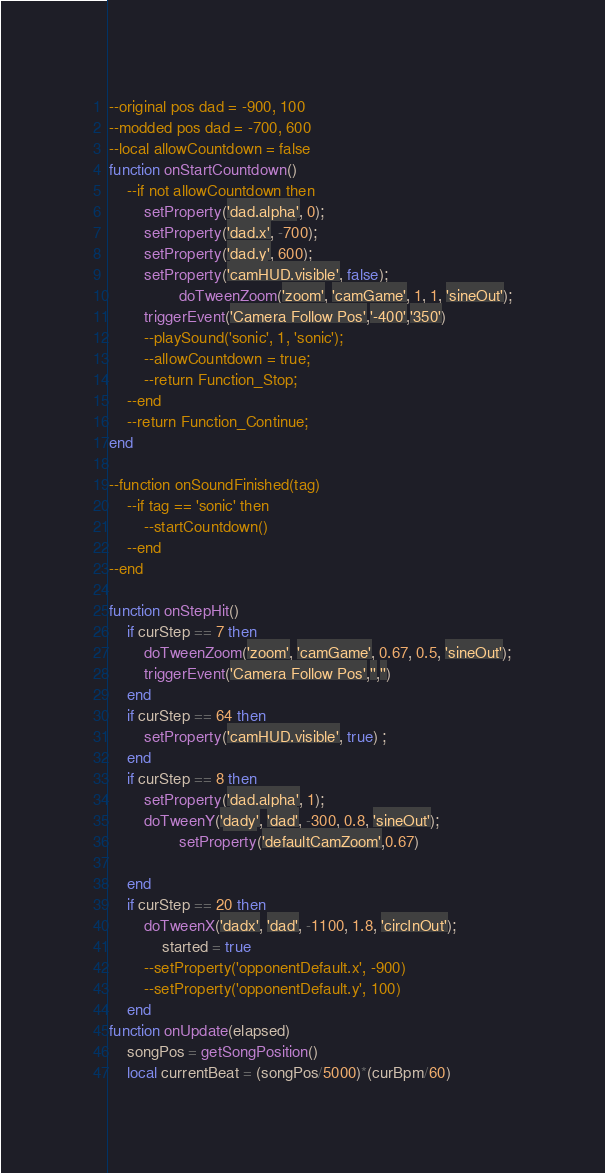<code> <loc_0><loc_0><loc_500><loc_500><_Lua_>--original pos dad = -900, 100
--modded pos dad = -700, 600
--local allowCountdown = false
function onStartCountdown()
	--if not allowCountdown then
		setProperty('dad.alpha', 0);
		setProperty('dad.x', -700);
		setProperty('dad.y', 600);
		setProperty('camHUD.visible', false);
            	doTweenZoom('zoom', 'camGame', 1, 1, 'sineOut');
		triggerEvent('Camera Follow Pos','-400','350')
		--playSound('sonic', 1, 'sonic');
		--allowCountdown = true;
		--return Function_Stop;
	--end
	--return Function_Continue;
end

--function onSoundFinished(tag)
	--if tag == 'sonic' then
		--startCountdown()
	--end
--end

function onStepHit()
	if curStep == 7 then
		doTweenZoom('zoom', 'camGame', 0.67, 0.5, 'sineOut');
		triggerEvent('Camera Follow Pos','','')
	end
	if curStep == 64 then
		setProperty('camHUD.visible', true) ;
	end
	if curStep == 8 then
		setProperty('dad.alpha', 1);
		doTweenY('dady', 'dad', -300, 0.8, 'sineOut');
            	setProperty('defaultCamZoom',0.67)

	end
	if curStep == 20 then
		doTweenX('dadx', 'dad', -1100, 1.8, 'circInOut');
	        started = true
		--setProperty('opponentDefault.x', -900)
		--setProperty('opponentDefault.y', 100)
	end
function onUpdate(elapsed)
	songPos = getSongPosition()
	local currentBeat = (songPos/5000)*(curBpm/60)</code> 